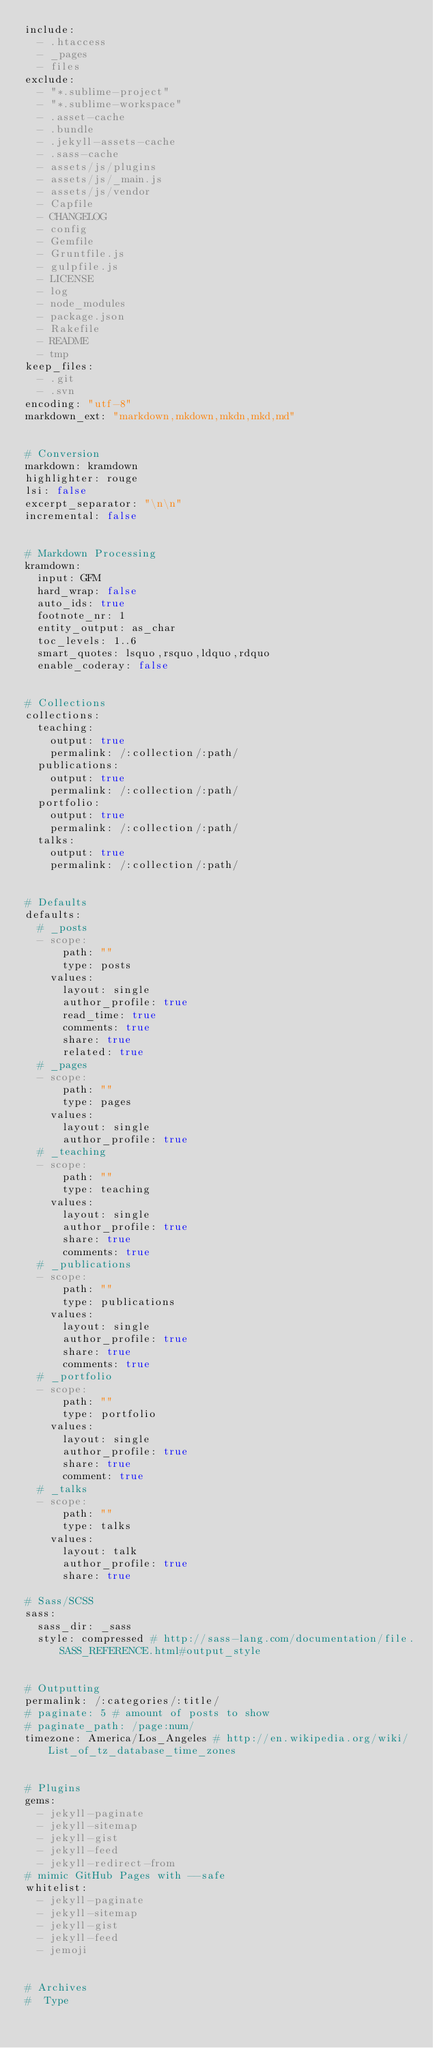<code> <loc_0><loc_0><loc_500><loc_500><_YAML_>include:
  - .htaccess
  - _pages
  - files
exclude:
  - "*.sublime-project"
  - "*.sublime-workspace"
  - .asset-cache
  - .bundle
  - .jekyll-assets-cache
  - .sass-cache
  - assets/js/plugins
  - assets/js/_main.js
  - assets/js/vendor
  - Capfile
  - CHANGELOG
  - config
  - Gemfile
  - Gruntfile.js
  - gulpfile.js
  - LICENSE
  - log
  - node_modules
  - package.json
  - Rakefile
  - README
  - tmp
keep_files:
  - .git
  - .svn
encoding: "utf-8"
markdown_ext: "markdown,mkdown,mkdn,mkd,md"


# Conversion
markdown: kramdown
highlighter: rouge
lsi: false
excerpt_separator: "\n\n"
incremental: false


# Markdown Processing
kramdown:
  input: GFM
  hard_wrap: false
  auto_ids: true
  footnote_nr: 1
  entity_output: as_char
  toc_levels: 1..6
  smart_quotes: lsquo,rsquo,ldquo,rdquo
  enable_coderay: false


# Collections
collections:
  teaching:
    output: true
    permalink: /:collection/:path/
  publications:
    output: true
    permalink: /:collection/:path/
  portfolio:
    output: true
    permalink: /:collection/:path/
  talks:
    output: true
    permalink: /:collection/:path/


# Defaults
defaults:
  # _posts
  - scope:
      path: ""
      type: posts
    values:
      layout: single
      author_profile: true
      read_time: true
      comments: true
      share: true
      related: true
  # _pages
  - scope:
      path: ""
      type: pages
    values:
      layout: single
      author_profile: true
  # _teaching
  - scope:
      path: ""
      type: teaching
    values:
      layout: single
      author_profile: true
      share: true
      comments: true
  # _publications
  - scope:
      path: ""
      type: publications
    values:
      layout: single
      author_profile: true
      share: true
      comments: true
  # _portfolio
  - scope:
      path: ""
      type: portfolio
    values:
      layout: single
      author_profile: true
      share: true
      comment: true
  # _talks
  - scope:
      path: ""
      type: talks
    values:
      layout: talk
      author_profile: true
      share: true

# Sass/SCSS
sass:
  sass_dir: _sass
  style: compressed # http://sass-lang.com/documentation/file.SASS_REFERENCE.html#output_style


# Outputting
permalink: /:categories/:title/
# paginate: 5 # amount of posts to show
# paginate_path: /page:num/
timezone: America/Los_Angeles # http://en.wikipedia.org/wiki/List_of_tz_database_time_zones


# Plugins
gems:
  - jekyll-paginate
  - jekyll-sitemap
  - jekyll-gist
  - jekyll-feed
  - jekyll-redirect-from
# mimic GitHub Pages with --safe
whitelist:
  - jekyll-paginate
  - jekyll-sitemap
  - jekyll-gist
  - jekyll-feed
  - jemoji


# Archives
#  Type</code> 